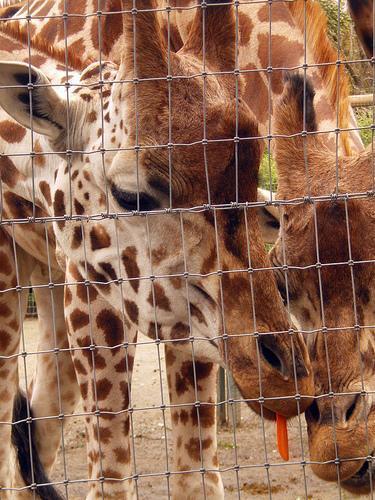How many eyes are visible from both giraffes?
Give a very brief answer. 2. How many legs are visible?
Give a very brief answer. 4. How many giraffes are visible?
Give a very brief answer. 2. 